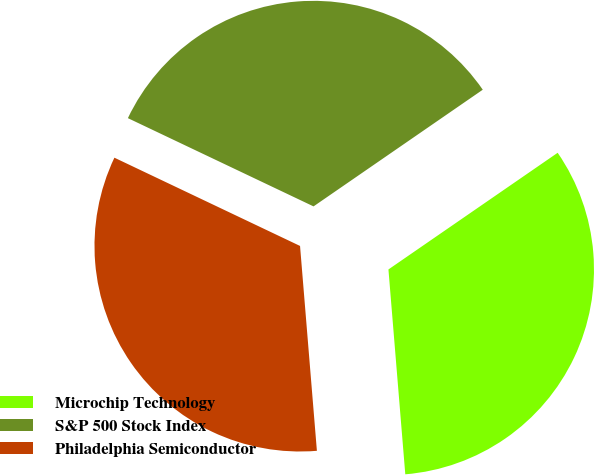Convert chart to OTSL. <chart><loc_0><loc_0><loc_500><loc_500><pie_chart><fcel>Microchip Technology<fcel>S&P 500 Stock Index<fcel>Philadelphia Semiconductor<nl><fcel>33.3%<fcel>33.33%<fcel>33.37%<nl></chart> 